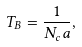<formula> <loc_0><loc_0><loc_500><loc_500>T _ { B } = \frac { 1 } { N _ { c } a } ,</formula> 